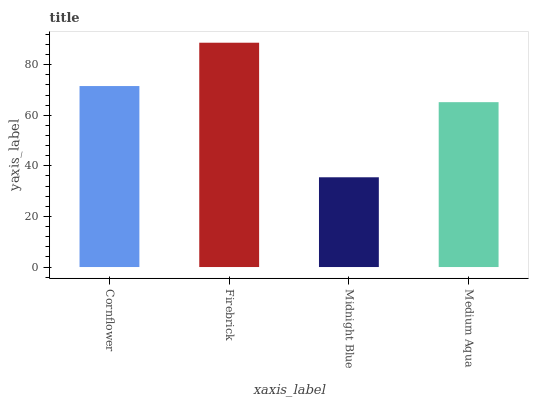Is Midnight Blue the minimum?
Answer yes or no. Yes. Is Firebrick the maximum?
Answer yes or no. Yes. Is Firebrick the minimum?
Answer yes or no. No. Is Midnight Blue the maximum?
Answer yes or no. No. Is Firebrick greater than Midnight Blue?
Answer yes or no. Yes. Is Midnight Blue less than Firebrick?
Answer yes or no. Yes. Is Midnight Blue greater than Firebrick?
Answer yes or no. No. Is Firebrick less than Midnight Blue?
Answer yes or no. No. Is Cornflower the high median?
Answer yes or no. Yes. Is Medium Aqua the low median?
Answer yes or no. Yes. Is Firebrick the high median?
Answer yes or no. No. Is Cornflower the low median?
Answer yes or no. No. 